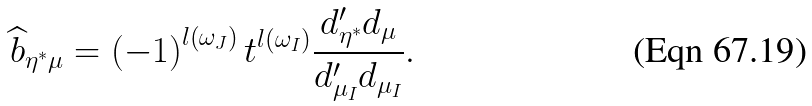<formula> <loc_0><loc_0><loc_500><loc_500>\widehat { b } _ { \eta ^ { \ast } \mu } = \left ( - 1 \right ) ^ { l \left ( \omega _ { J } \right ) } t ^ { l \left ( \omega _ { I } \right ) } \frac { d _ { \eta ^ { \ast } } ^ { \prime } d _ { \mu } } { d _ { \mu _ { I } } ^ { \prime } d _ { \mu _ { I } } } .</formula> 